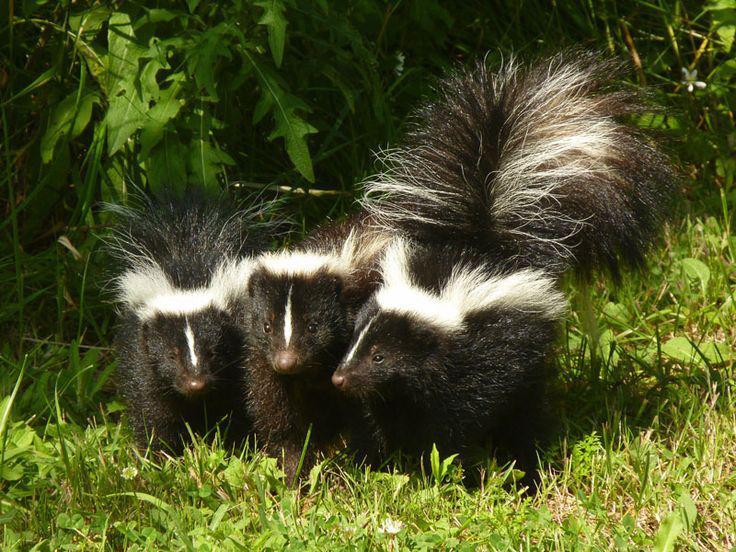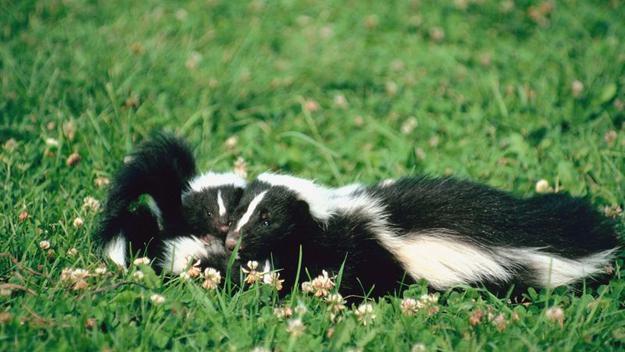The first image is the image on the left, the second image is the image on the right. Analyze the images presented: Is the assertion "An image shows a row of at least three skunks with their bodies turned forward, and at least one has its tail raised." valid? Answer yes or no. Yes. 